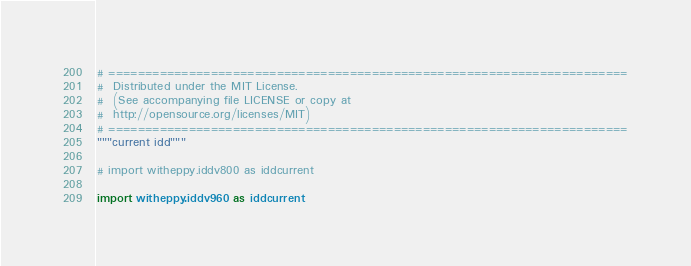<code> <loc_0><loc_0><loc_500><loc_500><_Python_># =======================================================================
#  Distributed under the MIT License.
#  (See accompanying file LICENSE or copy at
#  http://opensource.org/licenses/MIT)
# =======================================================================
"""current idd"""

# import witheppy.iddv800 as iddcurrent

import witheppy.iddv960 as iddcurrent
</code> 